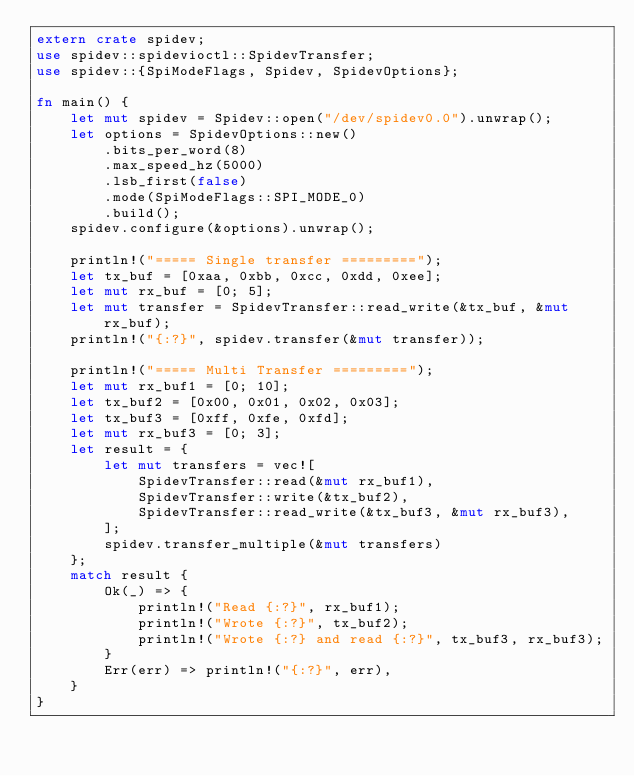<code> <loc_0><loc_0><loc_500><loc_500><_Rust_>extern crate spidev;
use spidev::spidevioctl::SpidevTransfer;
use spidev::{SpiModeFlags, Spidev, SpidevOptions};

fn main() {
    let mut spidev = Spidev::open("/dev/spidev0.0").unwrap();
    let options = SpidevOptions::new()
        .bits_per_word(8)
        .max_speed_hz(5000)
        .lsb_first(false)
        .mode(SpiModeFlags::SPI_MODE_0)
        .build();
    spidev.configure(&options).unwrap();

    println!("===== Single transfer =========");
    let tx_buf = [0xaa, 0xbb, 0xcc, 0xdd, 0xee];
    let mut rx_buf = [0; 5];
    let mut transfer = SpidevTransfer::read_write(&tx_buf, &mut rx_buf);
    println!("{:?}", spidev.transfer(&mut transfer));

    println!("===== Multi Transfer =========");
    let mut rx_buf1 = [0; 10];
    let tx_buf2 = [0x00, 0x01, 0x02, 0x03];
    let tx_buf3 = [0xff, 0xfe, 0xfd];
    let mut rx_buf3 = [0; 3];
    let result = {
        let mut transfers = vec![
            SpidevTransfer::read(&mut rx_buf1),
            SpidevTransfer::write(&tx_buf2),
            SpidevTransfer::read_write(&tx_buf3, &mut rx_buf3),
        ];
        spidev.transfer_multiple(&mut transfers)
    };
    match result {
        Ok(_) => {
            println!("Read {:?}", rx_buf1);
            println!("Wrote {:?}", tx_buf2);
            println!("Wrote {:?} and read {:?}", tx_buf3, rx_buf3);
        }
        Err(err) => println!("{:?}", err),
    }
}
</code> 